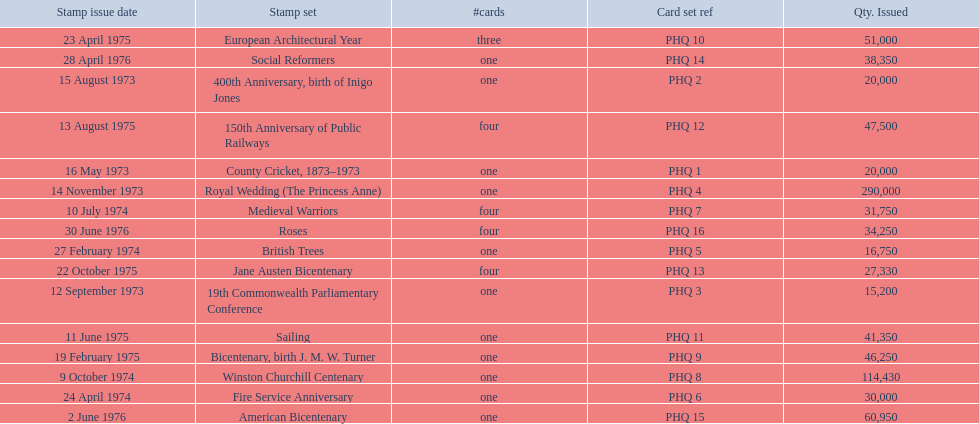Which stamp sets had three or more cards? Medieval Warriors, European Architectural Year, 150th Anniversary of Public Railways, Jane Austen Bicentenary, Roses. Of those, which one only has three cards? European Architectural Year. 